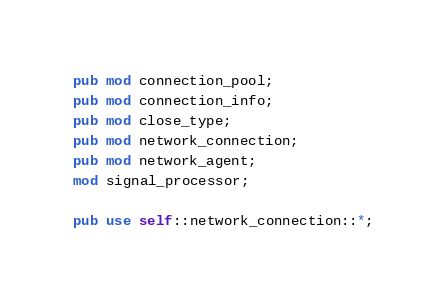Convert code to text. <code><loc_0><loc_0><loc_500><loc_500><_Rust_>pub mod connection_pool;
pub mod connection_info;
pub mod close_type;
pub mod network_connection;
pub mod network_agent;
mod signal_processor;

pub use self::network_connection::*;

</code> 